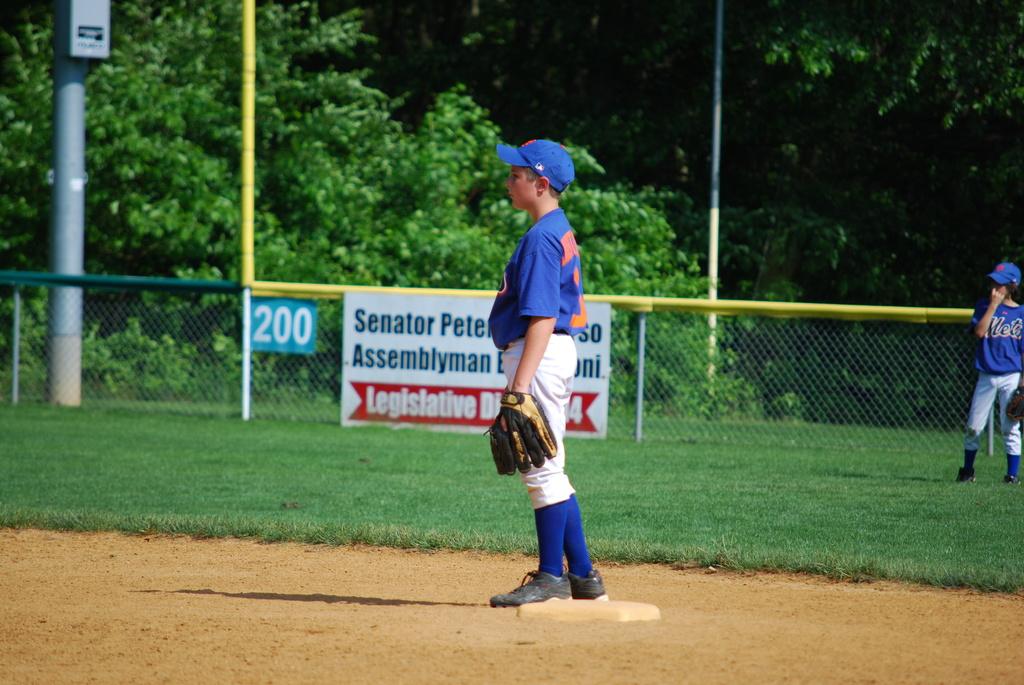What is the first name of the senator on the sign on the fence?
Provide a succinct answer. Pete. 